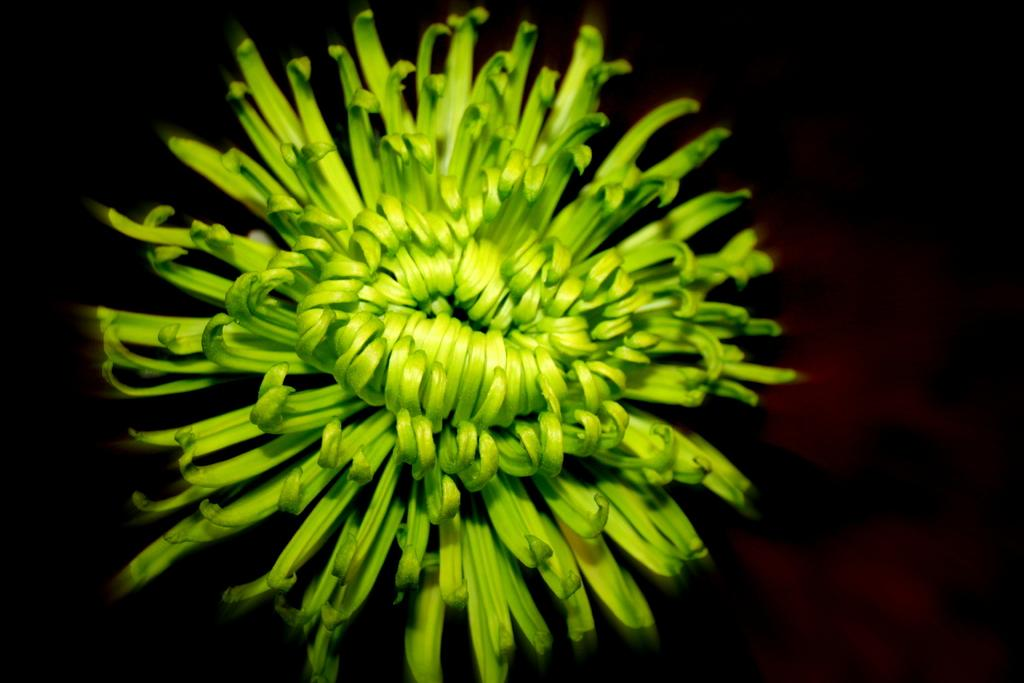What is the main subject of the image? There is a flower in the center of the image. Can you describe the flower in more detail? Unfortunately, the image does not provide enough detail to describe the flower further. Where is the calendar hanging in the image? There is no calendar present in the image; it only features a flower. What type of hook is used to hold the cub in the image? There is no cub or hook present in the image; it only features a flower. 